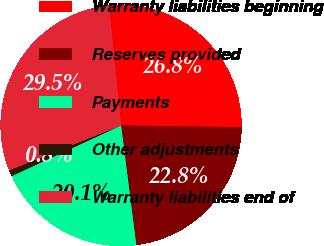<chart> <loc_0><loc_0><loc_500><loc_500><pie_chart><fcel>Warranty liabilities beginning<fcel>Reserves provided<fcel>Payments<fcel>Other adjustments<fcel>Warranty liabilities end of<nl><fcel>26.82%<fcel>22.76%<fcel>20.11%<fcel>0.83%<fcel>29.48%<nl></chart> 